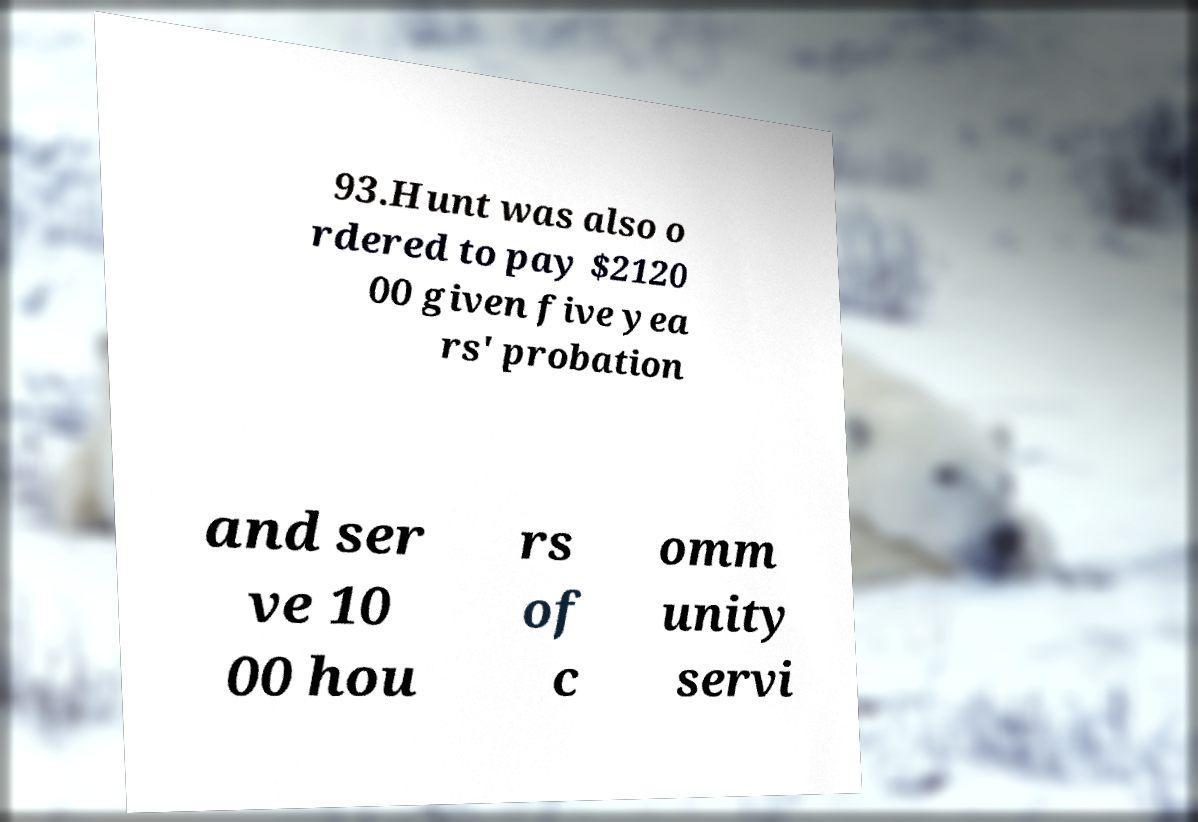I need the written content from this picture converted into text. Can you do that? 93.Hunt was also o rdered to pay $2120 00 given five yea rs' probation and ser ve 10 00 hou rs of c omm unity servi 